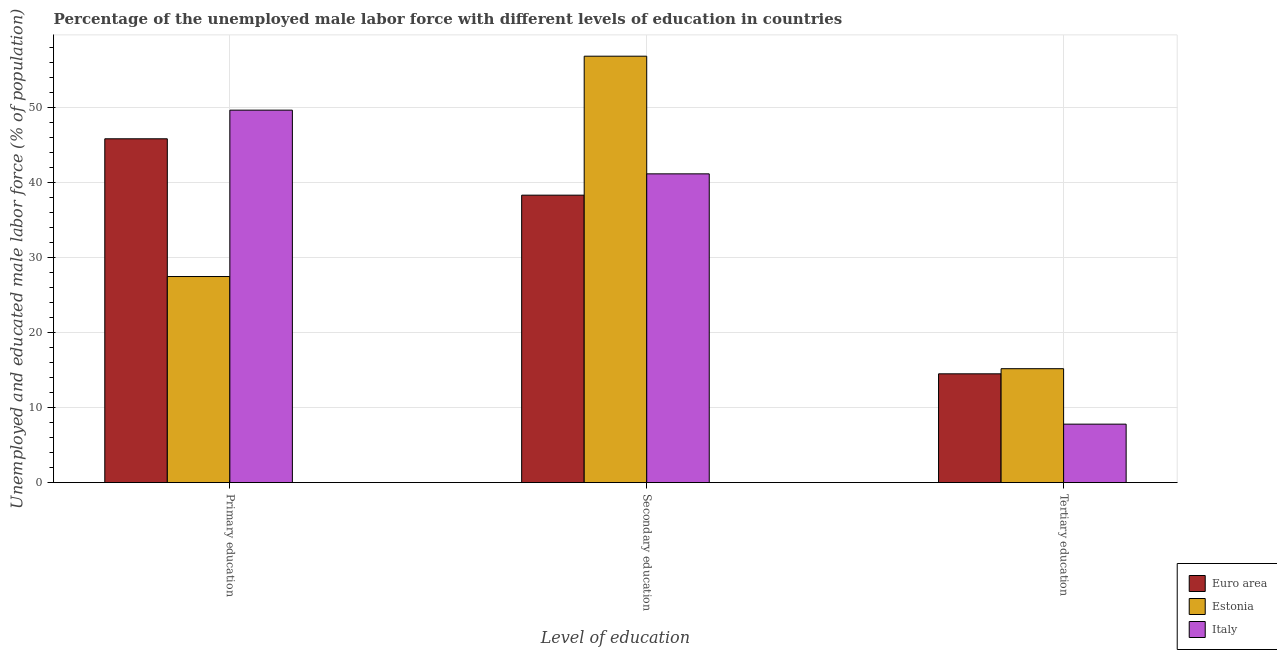How many different coloured bars are there?
Provide a succinct answer. 3. Are the number of bars on each tick of the X-axis equal?
Your answer should be very brief. Yes. How many bars are there on the 1st tick from the left?
Keep it short and to the point. 3. How many bars are there on the 1st tick from the right?
Provide a short and direct response. 3. What is the label of the 2nd group of bars from the left?
Your response must be concise. Secondary education. What is the percentage of male labor force who received primary education in Italy?
Keep it short and to the point. 49.7. Across all countries, what is the maximum percentage of male labor force who received tertiary education?
Offer a very short reply. 15.2. In which country was the percentage of male labor force who received tertiary education maximum?
Your answer should be very brief. Estonia. In which country was the percentage of male labor force who received primary education minimum?
Provide a succinct answer. Estonia. What is the total percentage of male labor force who received primary education in the graph?
Your answer should be compact. 123.08. What is the difference between the percentage of male labor force who received tertiary education in Euro area and that in Estonia?
Offer a very short reply. -0.68. What is the difference between the percentage of male labor force who received tertiary education in Euro area and the percentage of male labor force who received primary education in Estonia?
Offer a very short reply. -12.98. What is the average percentage of male labor force who received secondary education per country?
Offer a very short reply. 45.49. What is the difference between the percentage of male labor force who received tertiary education and percentage of male labor force who received secondary education in Estonia?
Offer a very short reply. -41.7. What is the ratio of the percentage of male labor force who received secondary education in Italy to that in Estonia?
Your answer should be compact. 0.72. What is the difference between the highest and the second highest percentage of male labor force who received tertiary education?
Offer a very short reply. 0.68. What is the difference between the highest and the lowest percentage of male labor force who received tertiary education?
Make the answer very short. 7.4. In how many countries, is the percentage of male labor force who received tertiary education greater than the average percentage of male labor force who received tertiary education taken over all countries?
Give a very brief answer. 2. Is the sum of the percentage of male labor force who received tertiary education in Estonia and Euro area greater than the maximum percentage of male labor force who received primary education across all countries?
Your answer should be very brief. No. What does the 1st bar from the left in Primary education represents?
Your response must be concise. Euro area. Is it the case that in every country, the sum of the percentage of male labor force who received primary education and percentage of male labor force who received secondary education is greater than the percentage of male labor force who received tertiary education?
Provide a succinct answer. Yes. How many bars are there?
Ensure brevity in your answer.  9. How many countries are there in the graph?
Offer a very short reply. 3. Does the graph contain grids?
Your answer should be compact. Yes. How are the legend labels stacked?
Make the answer very short. Vertical. What is the title of the graph?
Your answer should be compact. Percentage of the unemployed male labor force with different levels of education in countries. What is the label or title of the X-axis?
Offer a terse response. Level of education. What is the label or title of the Y-axis?
Your answer should be very brief. Unemployed and educated male labor force (% of population). What is the Unemployed and educated male labor force (% of population) in Euro area in Primary education?
Give a very brief answer. 45.88. What is the Unemployed and educated male labor force (% of population) of Estonia in Primary education?
Provide a succinct answer. 27.5. What is the Unemployed and educated male labor force (% of population) in Italy in Primary education?
Your response must be concise. 49.7. What is the Unemployed and educated male labor force (% of population) of Euro area in Secondary education?
Offer a very short reply. 38.36. What is the Unemployed and educated male labor force (% of population) of Estonia in Secondary education?
Provide a succinct answer. 56.9. What is the Unemployed and educated male labor force (% of population) in Italy in Secondary education?
Give a very brief answer. 41.2. What is the Unemployed and educated male labor force (% of population) in Euro area in Tertiary education?
Offer a terse response. 14.52. What is the Unemployed and educated male labor force (% of population) of Estonia in Tertiary education?
Your answer should be very brief. 15.2. What is the Unemployed and educated male labor force (% of population) of Italy in Tertiary education?
Provide a short and direct response. 7.8. Across all Level of education, what is the maximum Unemployed and educated male labor force (% of population) of Euro area?
Your answer should be compact. 45.88. Across all Level of education, what is the maximum Unemployed and educated male labor force (% of population) of Estonia?
Give a very brief answer. 56.9. Across all Level of education, what is the maximum Unemployed and educated male labor force (% of population) in Italy?
Provide a short and direct response. 49.7. Across all Level of education, what is the minimum Unemployed and educated male labor force (% of population) of Euro area?
Your response must be concise. 14.52. Across all Level of education, what is the minimum Unemployed and educated male labor force (% of population) of Estonia?
Make the answer very short. 15.2. Across all Level of education, what is the minimum Unemployed and educated male labor force (% of population) of Italy?
Keep it short and to the point. 7.8. What is the total Unemployed and educated male labor force (% of population) in Euro area in the graph?
Give a very brief answer. 98.75. What is the total Unemployed and educated male labor force (% of population) in Estonia in the graph?
Your response must be concise. 99.6. What is the total Unemployed and educated male labor force (% of population) of Italy in the graph?
Provide a succinct answer. 98.7. What is the difference between the Unemployed and educated male labor force (% of population) of Euro area in Primary education and that in Secondary education?
Provide a short and direct response. 7.52. What is the difference between the Unemployed and educated male labor force (% of population) of Estonia in Primary education and that in Secondary education?
Offer a terse response. -29.4. What is the difference between the Unemployed and educated male labor force (% of population) in Italy in Primary education and that in Secondary education?
Keep it short and to the point. 8.5. What is the difference between the Unemployed and educated male labor force (% of population) of Euro area in Primary education and that in Tertiary education?
Your response must be concise. 31.36. What is the difference between the Unemployed and educated male labor force (% of population) in Estonia in Primary education and that in Tertiary education?
Offer a terse response. 12.3. What is the difference between the Unemployed and educated male labor force (% of population) of Italy in Primary education and that in Tertiary education?
Provide a short and direct response. 41.9. What is the difference between the Unemployed and educated male labor force (% of population) in Euro area in Secondary education and that in Tertiary education?
Make the answer very short. 23.84. What is the difference between the Unemployed and educated male labor force (% of population) of Estonia in Secondary education and that in Tertiary education?
Give a very brief answer. 41.7. What is the difference between the Unemployed and educated male labor force (% of population) of Italy in Secondary education and that in Tertiary education?
Your answer should be very brief. 33.4. What is the difference between the Unemployed and educated male labor force (% of population) in Euro area in Primary education and the Unemployed and educated male labor force (% of population) in Estonia in Secondary education?
Provide a short and direct response. -11.02. What is the difference between the Unemployed and educated male labor force (% of population) in Euro area in Primary education and the Unemployed and educated male labor force (% of population) in Italy in Secondary education?
Offer a very short reply. 4.68. What is the difference between the Unemployed and educated male labor force (% of population) of Estonia in Primary education and the Unemployed and educated male labor force (% of population) of Italy in Secondary education?
Your response must be concise. -13.7. What is the difference between the Unemployed and educated male labor force (% of population) in Euro area in Primary education and the Unemployed and educated male labor force (% of population) in Estonia in Tertiary education?
Ensure brevity in your answer.  30.68. What is the difference between the Unemployed and educated male labor force (% of population) in Euro area in Primary education and the Unemployed and educated male labor force (% of population) in Italy in Tertiary education?
Give a very brief answer. 38.08. What is the difference between the Unemployed and educated male labor force (% of population) in Estonia in Primary education and the Unemployed and educated male labor force (% of population) in Italy in Tertiary education?
Ensure brevity in your answer.  19.7. What is the difference between the Unemployed and educated male labor force (% of population) of Euro area in Secondary education and the Unemployed and educated male labor force (% of population) of Estonia in Tertiary education?
Give a very brief answer. 23.16. What is the difference between the Unemployed and educated male labor force (% of population) in Euro area in Secondary education and the Unemployed and educated male labor force (% of population) in Italy in Tertiary education?
Provide a succinct answer. 30.56. What is the difference between the Unemployed and educated male labor force (% of population) in Estonia in Secondary education and the Unemployed and educated male labor force (% of population) in Italy in Tertiary education?
Make the answer very short. 49.1. What is the average Unemployed and educated male labor force (% of population) of Euro area per Level of education?
Keep it short and to the point. 32.92. What is the average Unemployed and educated male labor force (% of population) of Estonia per Level of education?
Ensure brevity in your answer.  33.2. What is the average Unemployed and educated male labor force (% of population) in Italy per Level of education?
Provide a succinct answer. 32.9. What is the difference between the Unemployed and educated male labor force (% of population) of Euro area and Unemployed and educated male labor force (% of population) of Estonia in Primary education?
Offer a very short reply. 18.38. What is the difference between the Unemployed and educated male labor force (% of population) in Euro area and Unemployed and educated male labor force (% of population) in Italy in Primary education?
Ensure brevity in your answer.  -3.82. What is the difference between the Unemployed and educated male labor force (% of population) in Estonia and Unemployed and educated male labor force (% of population) in Italy in Primary education?
Provide a succinct answer. -22.2. What is the difference between the Unemployed and educated male labor force (% of population) in Euro area and Unemployed and educated male labor force (% of population) in Estonia in Secondary education?
Make the answer very short. -18.54. What is the difference between the Unemployed and educated male labor force (% of population) of Euro area and Unemployed and educated male labor force (% of population) of Italy in Secondary education?
Keep it short and to the point. -2.84. What is the difference between the Unemployed and educated male labor force (% of population) of Euro area and Unemployed and educated male labor force (% of population) of Estonia in Tertiary education?
Make the answer very short. -0.68. What is the difference between the Unemployed and educated male labor force (% of population) of Euro area and Unemployed and educated male labor force (% of population) of Italy in Tertiary education?
Provide a succinct answer. 6.72. What is the ratio of the Unemployed and educated male labor force (% of population) of Euro area in Primary education to that in Secondary education?
Ensure brevity in your answer.  1.2. What is the ratio of the Unemployed and educated male labor force (% of population) in Estonia in Primary education to that in Secondary education?
Give a very brief answer. 0.48. What is the ratio of the Unemployed and educated male labor force (% of population) in Italy in Primary education to that in Secondary education?
Provide a succinct answer. 1.21. What is the ratio of the Unemployed and educated male labor force (% of population) of Euro area in Primary education to that in Tertiary education?
Your answer should be very brief. 3.16. What is the ratio of the Unemployed and educated male labor force (% of population) of Estonia in Primary education to that in Tertiary education?
Provide a succinct answer. 1.81. What is the ratio of the Unemployed and educated male labor force (% of population) in Italy in Primary education to that in Tertiary education?
Make the answer very short. 6.37. What is the ratio of the Unemployed and educated male labor force (% of population) of Euro area in Secondary education to that in Tertiary education?
Make the answer very short. 2.64. What is the ratio of the Unemployed and educated male labor force (% of population) of Estonia in Secondary education to that in Tertiary education?
Offer a very short reply. 3.74. What is the ratio of the Unemployed and educated male labor force (% of population) of Italy in Secondary education to that in Tertiary education?
Your response must be concise. 5.28. What is the difference between the highest and the second highest Unemployed and educated male labor force (% of population) in Euro area?
Make the answer very short. 7.52. What is the difference between the highest and the second highest Unemployed and educated male labor force (% of population) of Estonia?
Your answer should be compact. 29.4. What is the difference between the highest and the lowest Unemployed and educated male labor force (% of population) of Euro area?
Your answer should be compact. 31.36. What is the difference between the highest and the lowest Unemployed and educated male labor force (% of population) of Estonia?
Ensure brevity in your answer.  41.7. What is the difference between the highest and the lowest Unemployed and educated male labor force (% of population) in Italy?
Give a very brief answer. 41.9. 